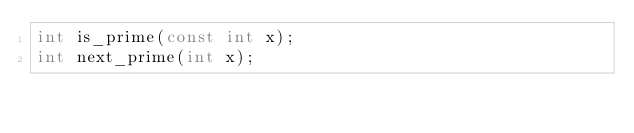Convert code to text. <code><loc_0><loc_0><loc_500><loc_500><_C_>int is_prime(const int x);
int next_prime(int x);</code> 